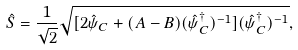Convert formula to latex. <formula><loc_0><loc_0><loc_500><loc_500>\hat { S } = \frac { 1 } { \sqrt { 2 } } \sqrt { [ 2 \hat { \psi } _ { C } + ( A - B ) ( \hat { \psi } _ { C } ^ { \dag } ) ^ { - 1 } ] ( \hat { \psi } _ { C } ^ { \dag } ) ^ { - 1 } } ,</formula> 